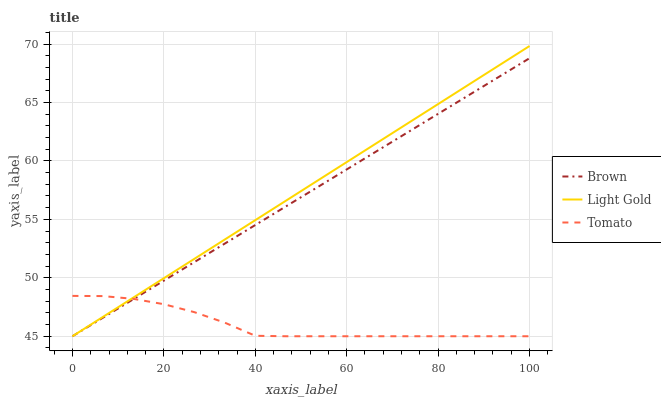Does Tomato have the minimum area under the curve?
Answer yes or no. Yes. Does Light Gold have the maximum area under the curve?
Answer yes or no. Yes. Does Brown have the minimum area under the curve?
Answer yes or no. No. Does Brown have the maximum area under the curve?
Answer yes or no. No. Is Light Gold the smoothest?
Answer yes or no. Yes. Is Tomato the roughest?
Answer yes or no. Yes. Is Brown the smoothest?
Answer yes or no. No. Is Brown the roughest?
Answer yes or no. No. Does Tomato have the lowest value?
Answer yes or no. Yes. Does Light Gold have the highest value?
Answer yes or no. Yes. Does Brown have the highest value?
Answer yes or no. No. Does Brown intersect Light Gold?
Answer yes or no. Yes. Is Brown less than Light Gold?
Answer yes or no. No. Is Brown greater than Light Gold?
Answer yes or no. No. 